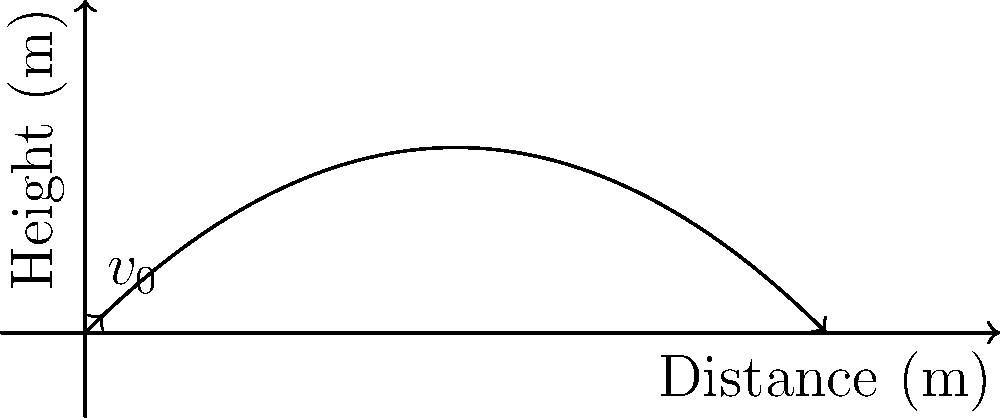As a former football player, you're familiar with the perfect spiral throw. Consider a football thrown with an initial velocity of 20 m/s at a 45-degree angle to the horizontal. Assuming no air resistance, what is the maximum height reached by the football during its flight? Let's approach this step-by-step:

1) The trajectory of the football follows a parabolic path, described by the equations of motion for projectile motion.

2) The maximum height is reached when the vertical velocity component becomes zero.

3) The time to reach the maximum height is given by:
   $$t_{max} = \frac{v_0 \sin \theta}{g}$$
   where $v_0$ is the initial velocity, $\theta$ is the launch angle, and $g$ is the acceleration due to gravity.

4) Given:
   $v_0 = 20$ m/s
   $\theta = 45°$ (or $\pi/4$ radians)
   $g = 9.81$ m/s²

5) Calculate the time to reach maximum height:
   $$t_{max} = \frac{20 \sin (45°)}{9.81} = \frac{20 \cdot 0.707}{9.81} = 1.44 \text{ seconds}$$

6) The maximum height is given by:
   $$h_{max} = v_0 \sin \theta \cdot t_{max} - \frac{1}{2}gt_{max}^2$$

7) Substitute the values:
   $$h_{max} = 20 \sin (45°) \cdot 1.44 - \frac{1}{2} \cdot 9.81 \cdot 1.44^2$$
   $$h_{max} = 20 \cdot 0.707 \cdot 1.44 - \frac{1}{2} \cdot 9.81 \cdot 2.07$$
   $$h_{max} = 20.36 - 10.15 = 10.21 \text{ meters}$$

Therefore, the maximum height reached by the football is approximately 10.21 meters.
Answer: 10.21 meters 